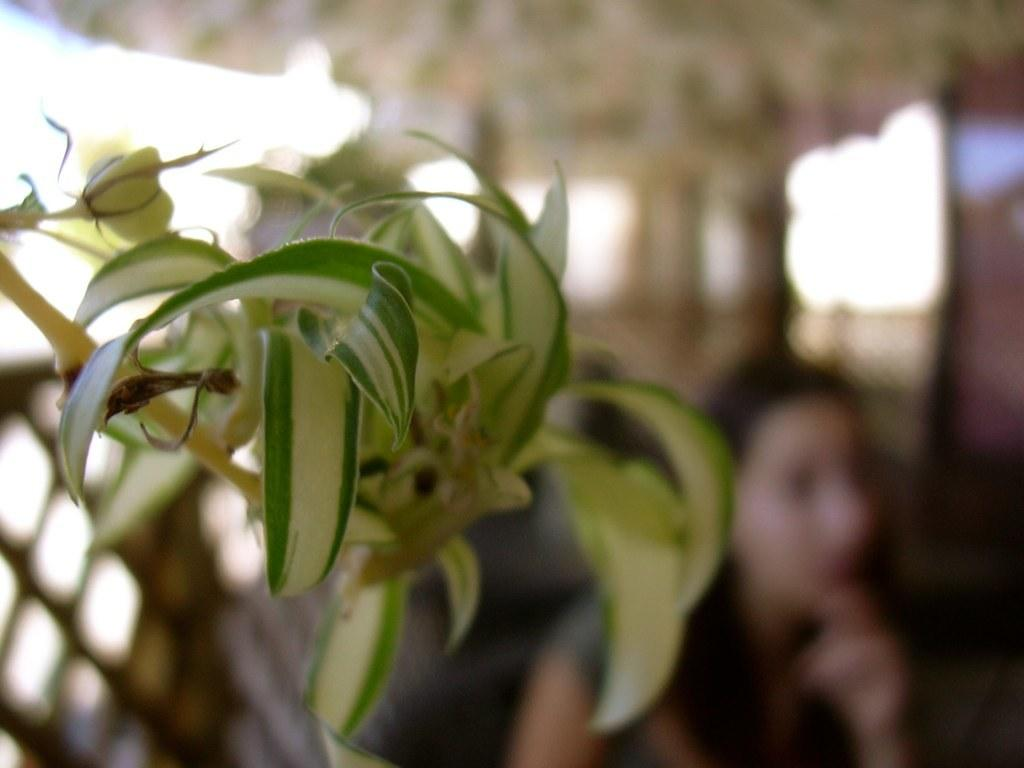What is the dominant color in the image? The image has a blue color. What type of living organism can be seen in the image? There is a plant in the image. Can you describe the woman in the background of the image? There is a woman in the background of the image. What type of humor is the robin displaying in the image? There is no robin present in the image, so it is not possible to determine what type of humor it might be displaying. 